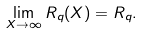<formula> <loc_0><loc_0><loc_500><loc_500>\lim _ { X \rightarrow \infty } R _ { q } ( X ) = R _ { q } .</formula> 